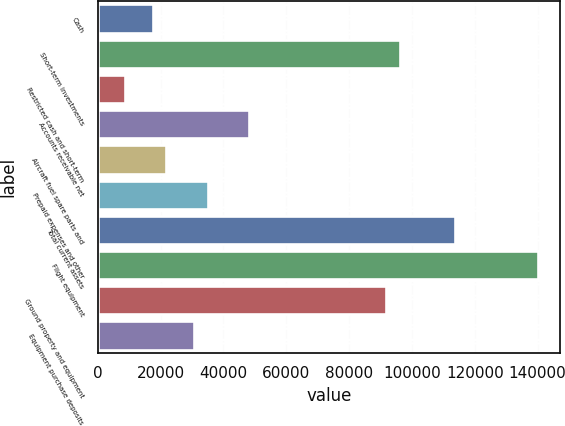Convert chart to OTSL. <chart><loc_0><loc_0><loc_500><loc_500><bar_chart><fcel>Cash<fcel>Short-term investments<fcel>Restricted cash and short-term<fcel>Accounts receivable net<fcel>Aircraft fuel spare parts and<fcel>Prepaid expenses and other<fcel>Total current assets<fcel>Flight equipment<fcel>Ground property and equipment<fcel>Equipment purchase deposits<nl><fcel>17512.6<fcel>96287.8<fcel>8759.8<fcel>48147.4<fcel>21889<fcel>35018.2<fcel>113793<fcel>140052<fcel>91911.4<fcel>30641.8<nl></chart> 